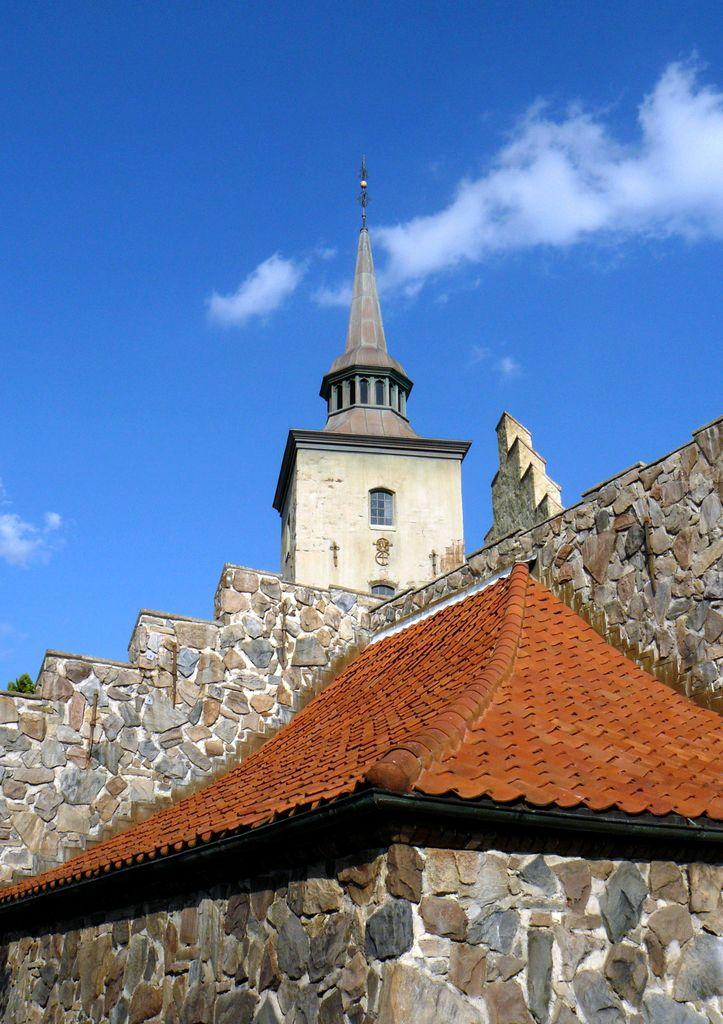What type of structure is present in the image? There is a building in the image. What colors are used on the building? The building has brown and cream colors. What can be seen in the background of the image? The sky is visible in the background of the image. What colors are present in the sky? The sky has blue and white colors. How many cats are coughing in the image? There are no cats or coughing sounds present in the image. What type of punishment is being given to the person in the image? There is no person or punishment being depicted in the image; it only features a building and the sky. 